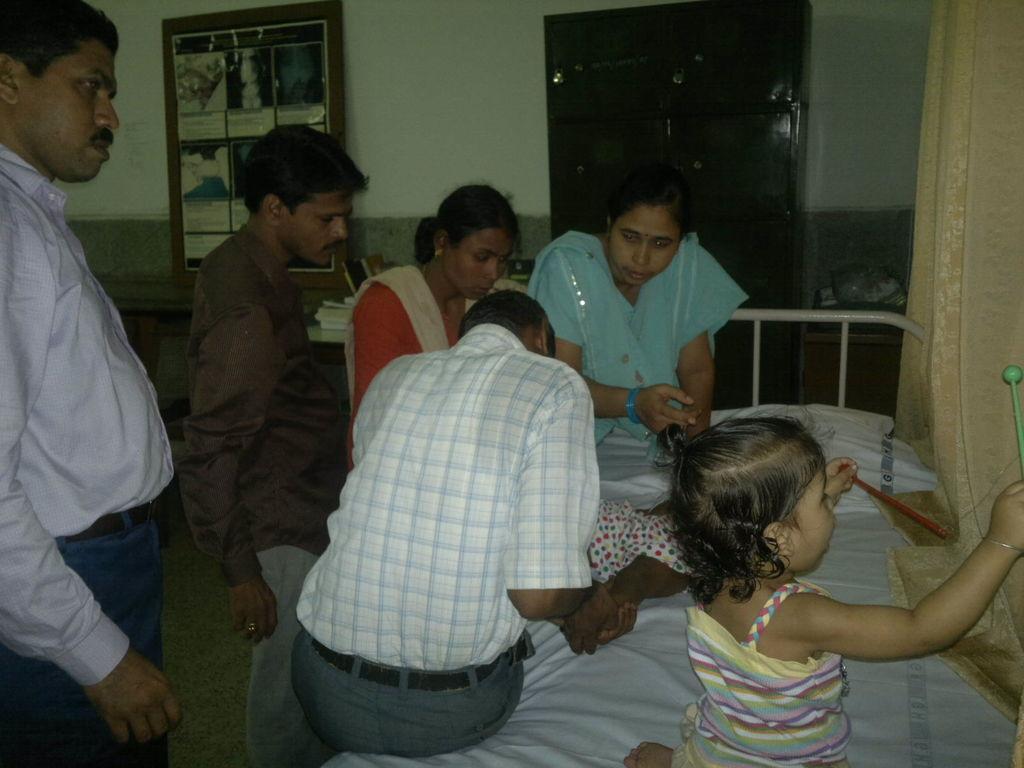How would you summarize this image in a sentence or two? This picture is taken inside the room. In this image, on the right side, we can see four people are sitting on the bed, we can also see a kid lying on the bed. On the left side, we can see two men are standing. In the background, we can see glass door and posters which are attached to a wall and some books which are placed on the table, wall. On the right side, we can also see a curtain. 